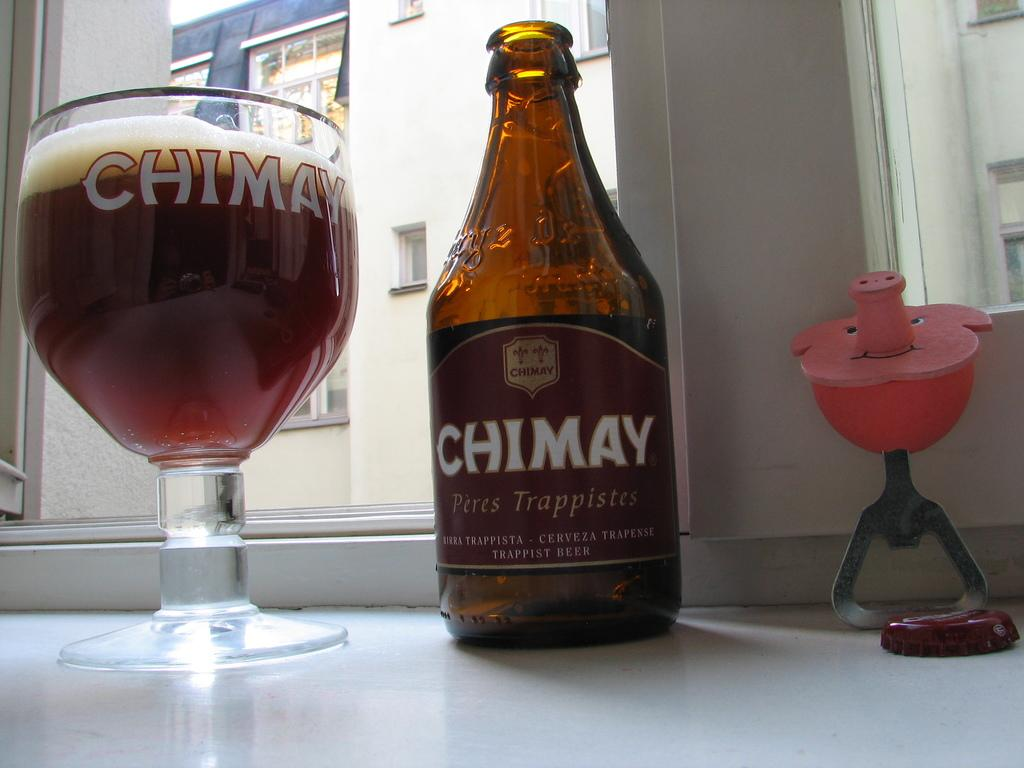<image>
Write a terse but informative summary of the picture. A bottle of Chimay, a glass beside it and a pig bottle opener. 